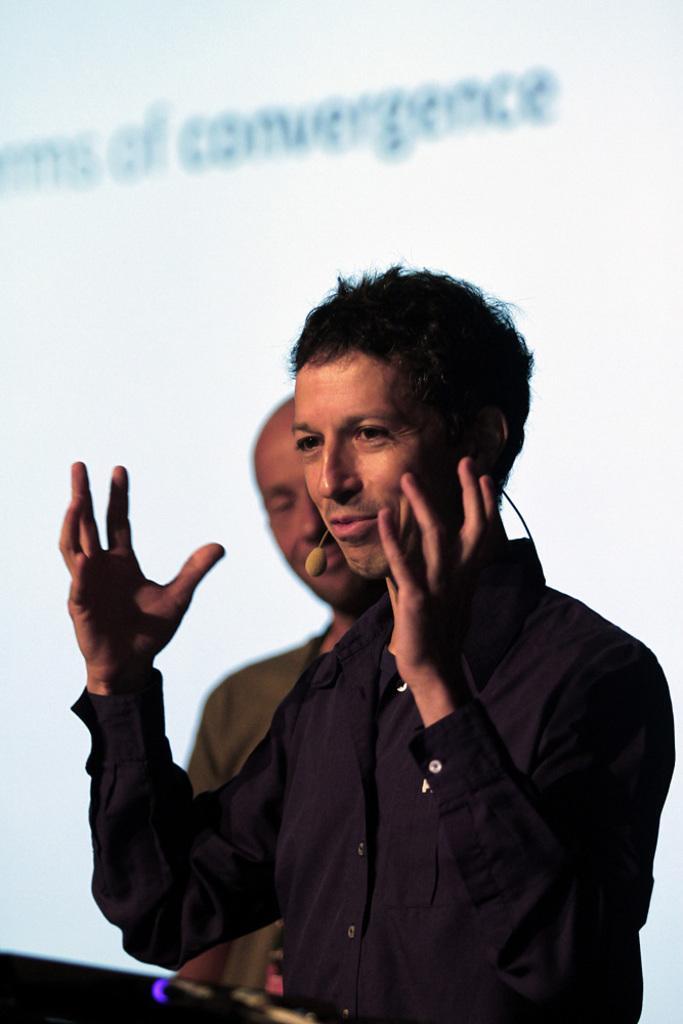Could you give a brief overview of what you see in this image? In this image we can see a man and he wore a mike. At the bottom of the image we can see a black color object which is truncated. In the background we can see a person and text written on a screen. 